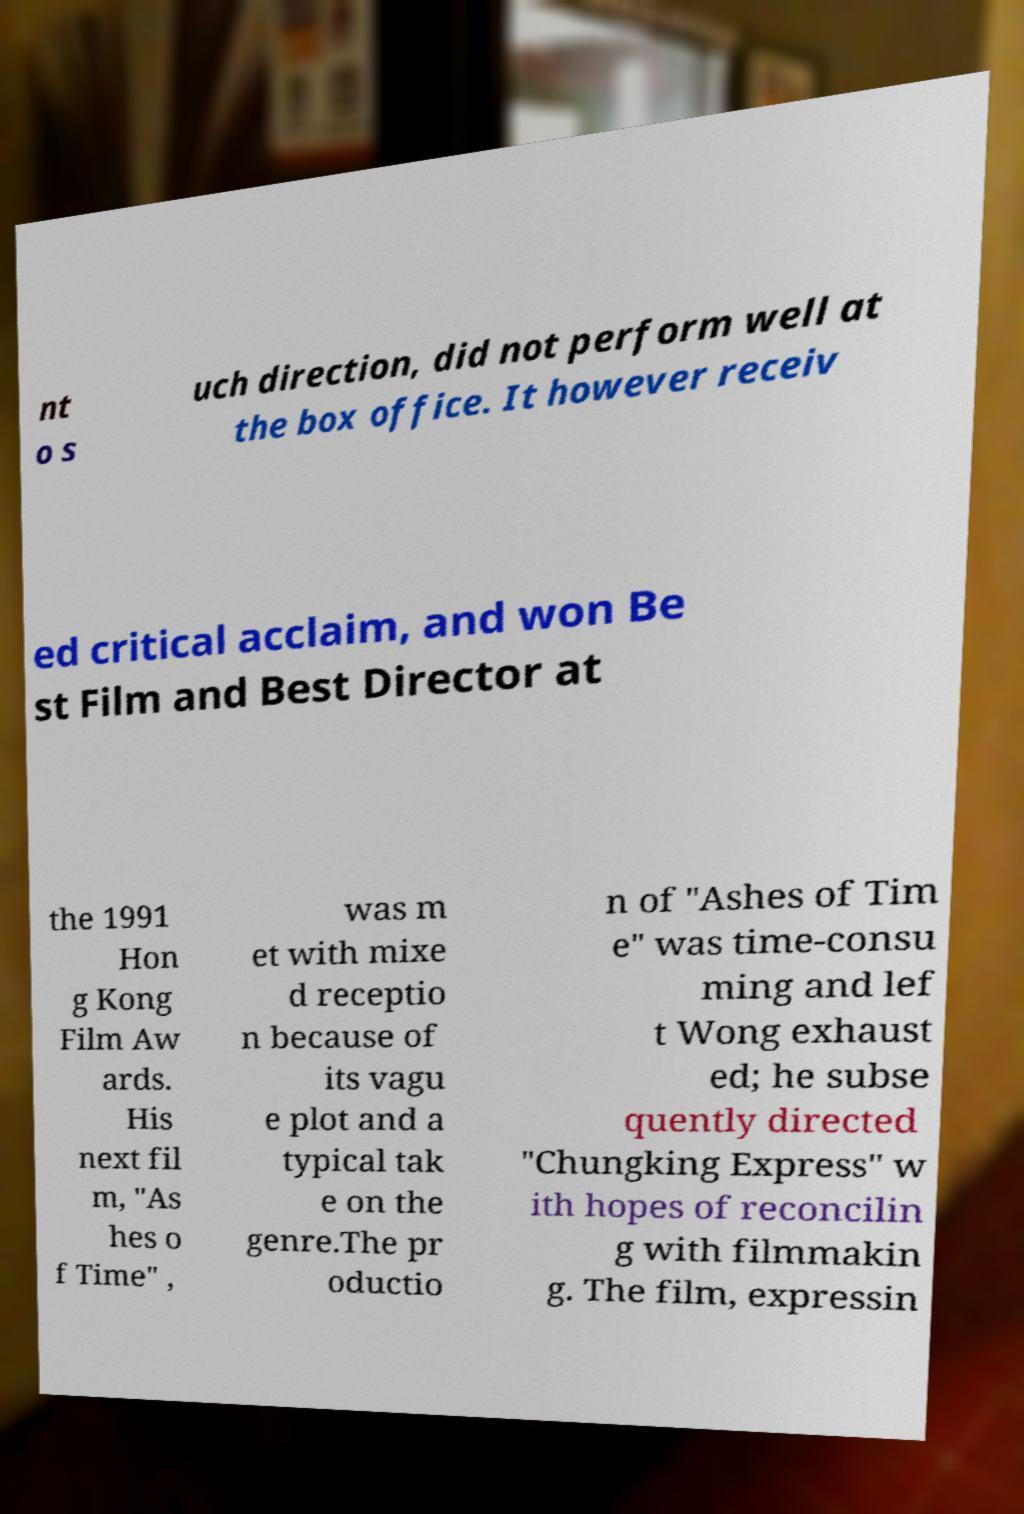I need the written content from this picture converted into text. Can you do that? nt o s uch direction, did not perform well at the box office. It however receiv ed critical acclaim, and won Be st Film and Best Director at the 1991 Hon g Kong Film Aw ards. His next fil m, "As hes o f Time" , was m et with mixe d receptio n because of its vagu e plot and a typical tak e on the genre.The pr oductio n of "Ashes of Tim e" was time-consu ming and lef t Wong exhaust ed; he subse quently directed "Chungking Express" w ith hopes of reconcilin g with filmmakin g. The film, expressin 